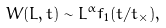Convert formula to latex. <formula><loc_0><loc_0><loc_500><loc_500>W ( L , t ) \sim L ^ { \alpha } f _ { 1 } ( t / t _ { \times } ) ,</formula> 